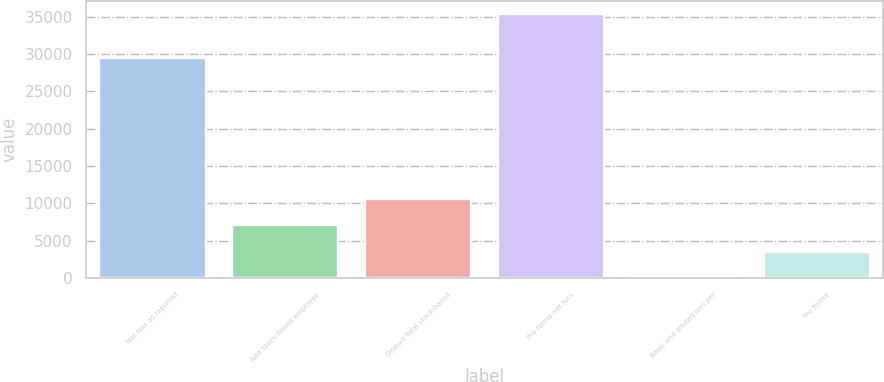Convert chart to OTSL. <chart><loc_0><loc_0><loc_500><loc_500><bar_chart><fcel>Net loss as reported<fcel>Add Stock-based employee<fcel>Deduct Total stock-based<fcel>Pro forma net loss<fcel>Basic and diluted loss per<fcel>Pro forma<nl><fcel>29449<fcel>7084.12<fcel>10625.6<fcel>35416<fcel>1.15<fcel>3542.64<nl></chart> 